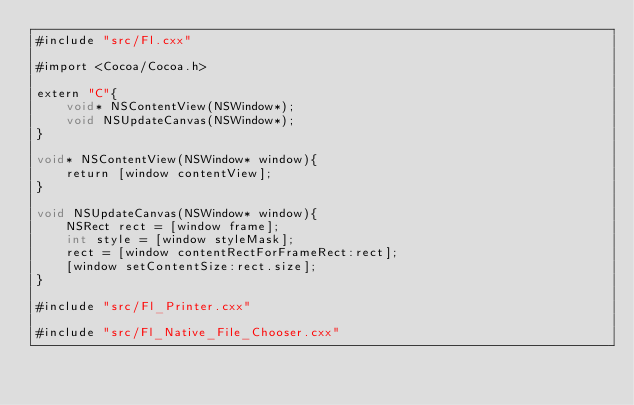<code> <loc_0><loc_0><loc_500><loc_500><_ObjectiveC_>#include "src/Fl.cxx"

#import <Cocoa/Cocoa.h>

extern "C"{
	void* NSContentView(NSWindow*);
	void NSUpdateCanvas(NSWindow*);
}

void* NSContentView(NSWindow* window){
	return [window contentView];
}

void NSUpdateCanvas(NSWindow* window){
	NSRect rect = [window frame];
	int style = [window styleMask];
	rect = [window contentRectForFrameRect:rect];
	[window setContentSize:rect.size];
}

#include "src/Fl_Printer.cxx"

#include "src/Fl_Native_File_Chooser.cxx"</code> 